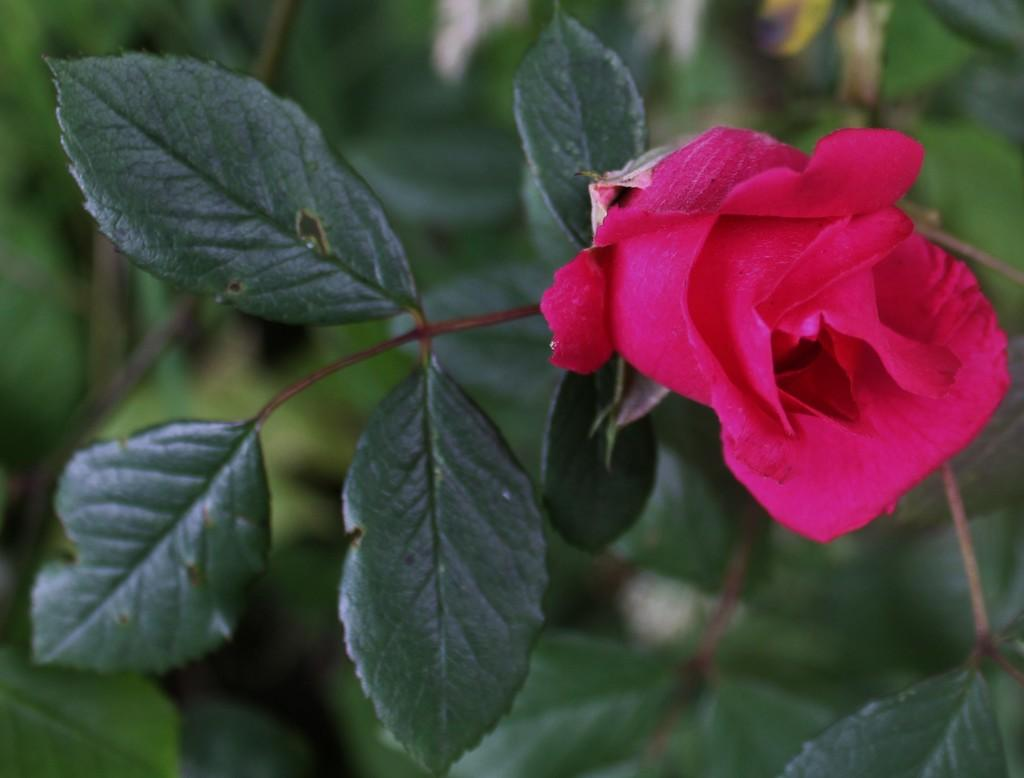What type of plant is present in the image? There is a flower in the image. What other parts of the plant can be seen in the image? There are leaves and stems in the image. How would you describe the background of the image? The background of the image is blurry. What new theory about the flower is being discussed in the image? There is no discussion or theory present in the image; it simply shows a flower, leaves, and stems. What time of day is it in the image? The time of day is not visible or discernible in the image. 